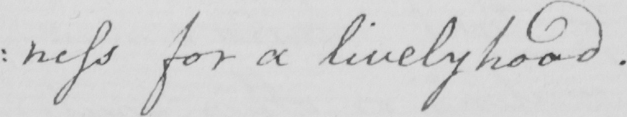Can you read and transcribe this handwriting? : ness for a livelyhood . 